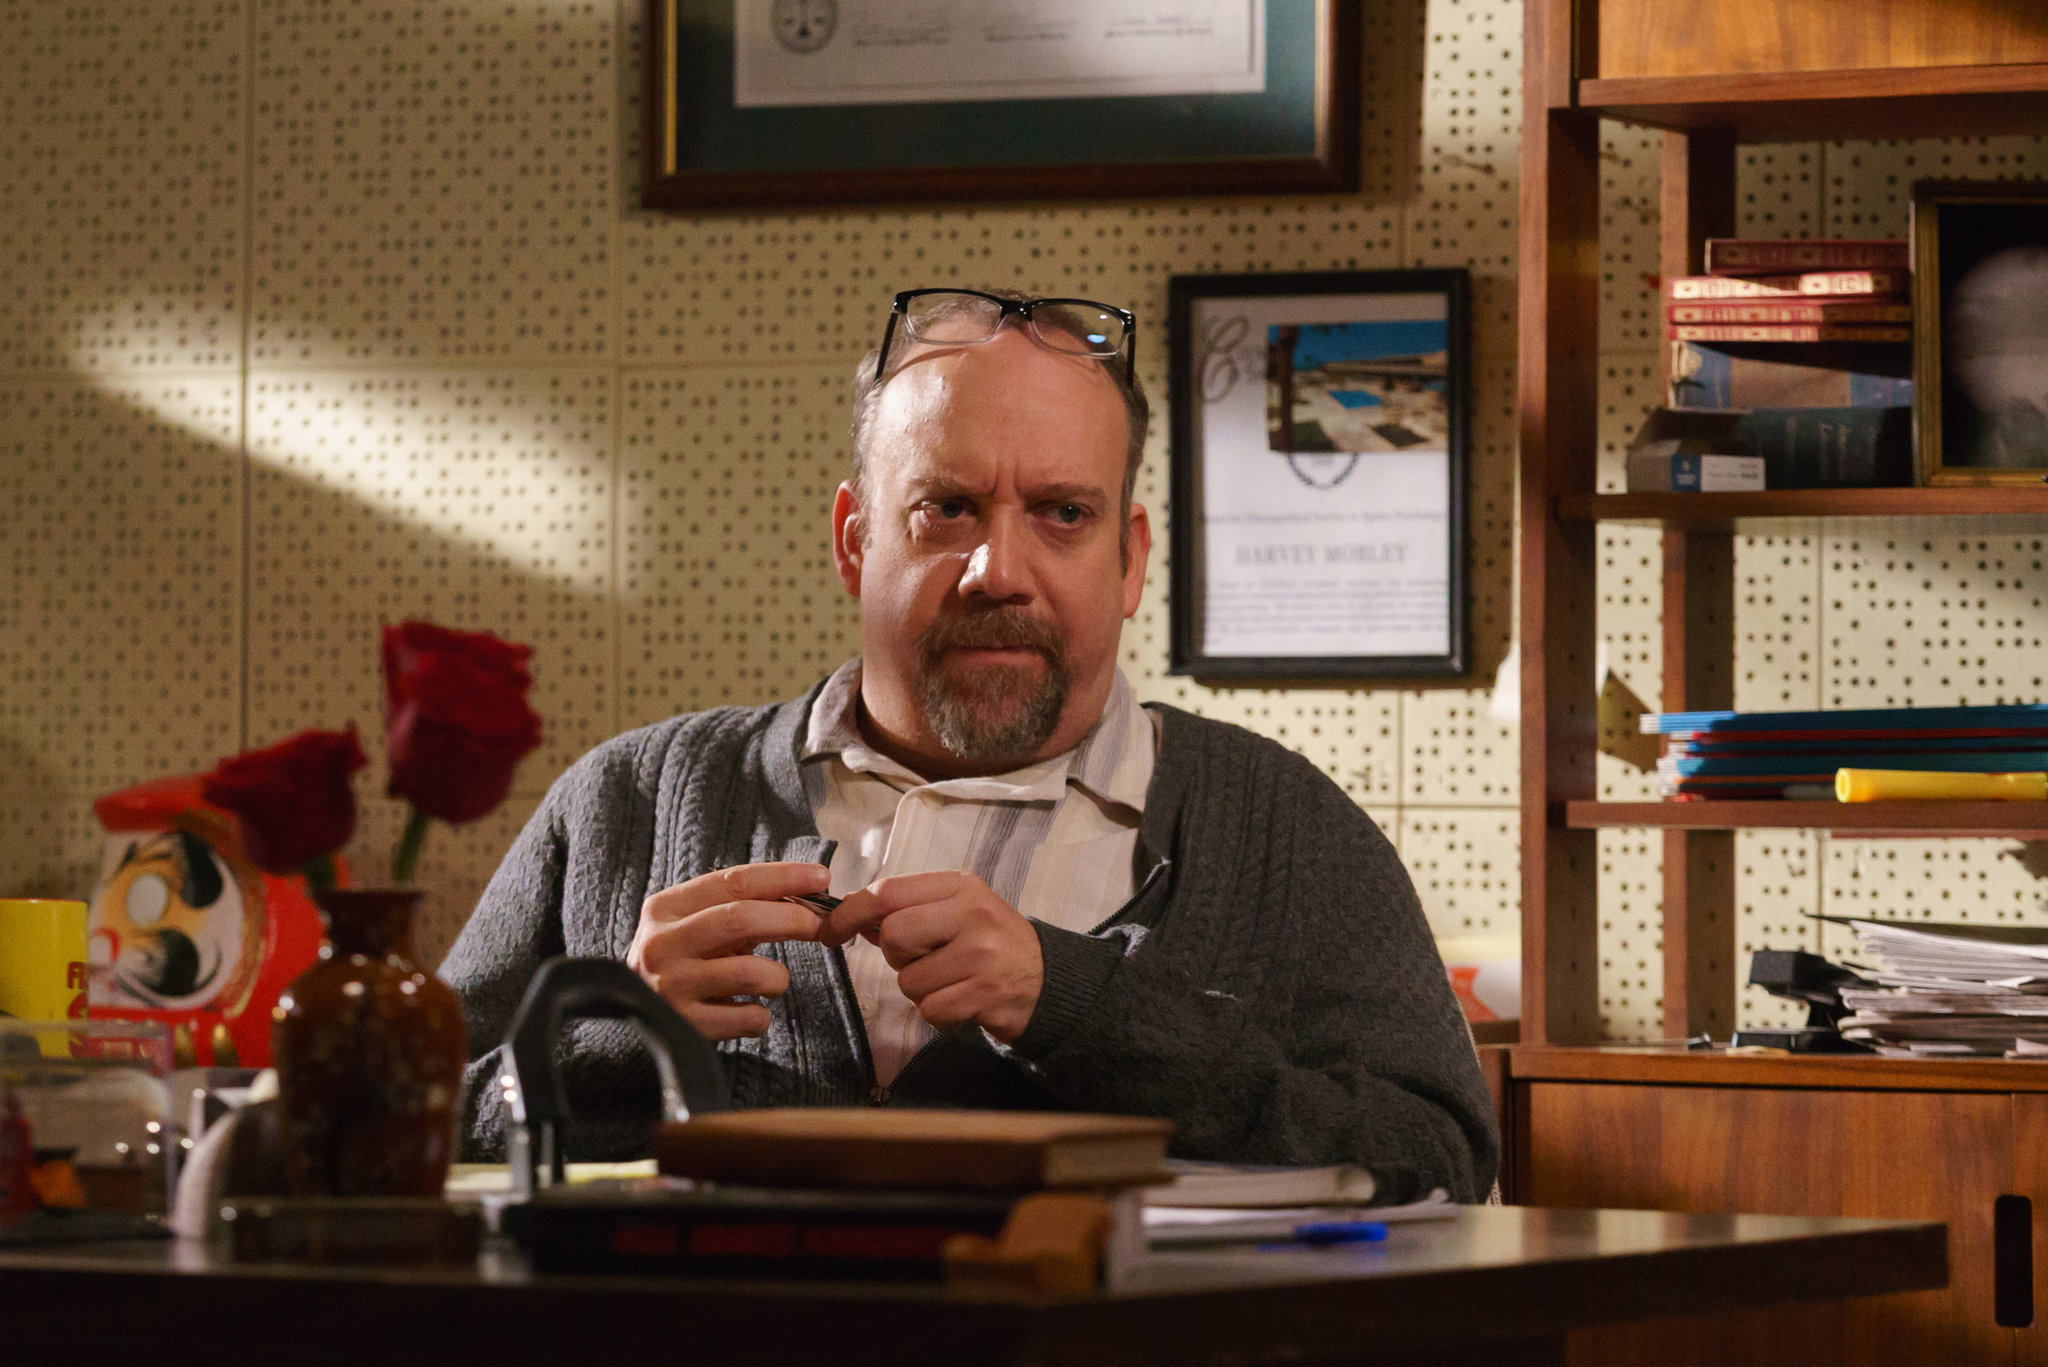Imagine the man in the image is a character in a novel. What might be his backstory? In the novel, the man could be portrayed as Dr. Harold Thompson, a reclusive historian who spent years unraveling ancient mysteries and hidden truths. Born to a modest family, Harold's insatiable curiosity led him to pursue extensive education, eventually earning him a PhD in History. His humble office, filled with a plethora of books and documents, exemplifies his dedication to his work. The framed certificates are a testament to his scholarly achievements, while the personal items on his desk, such as the vase with red roses, might represent cherished memories of his late wife, lending emotional depth to his solitary existence. Harold's journey through the labyrinth of time has rendered him both a sage and a recluse, deeply engrossed in his quest for knowledge yet wistfully detached from the present. What might be the pivotal moment in Dr. Harold Thompson’s life that led him to a turning point? The pivotal moment in Dr. Harold Thompson's life may have occurred during a particularly arduous research expedition in Egypt, where he discovered a set of ancient scrolls in a long-lost tomb. This incredible find not only secured his place in academia but also revealed cryptic references to a hidden truth about civilization's origins, a mystery that has haunted him ever since. However, the journey came at a great personal cost as he lost his beloved wife to an unexpected illness while he was away. This tragic event fueled his relentless pursuit of the truth, driving him to the brink of obsession. The contrast between his professional triumph and personal loss created a dichotomy within him, making this moment the axis upon which his character pivots. 